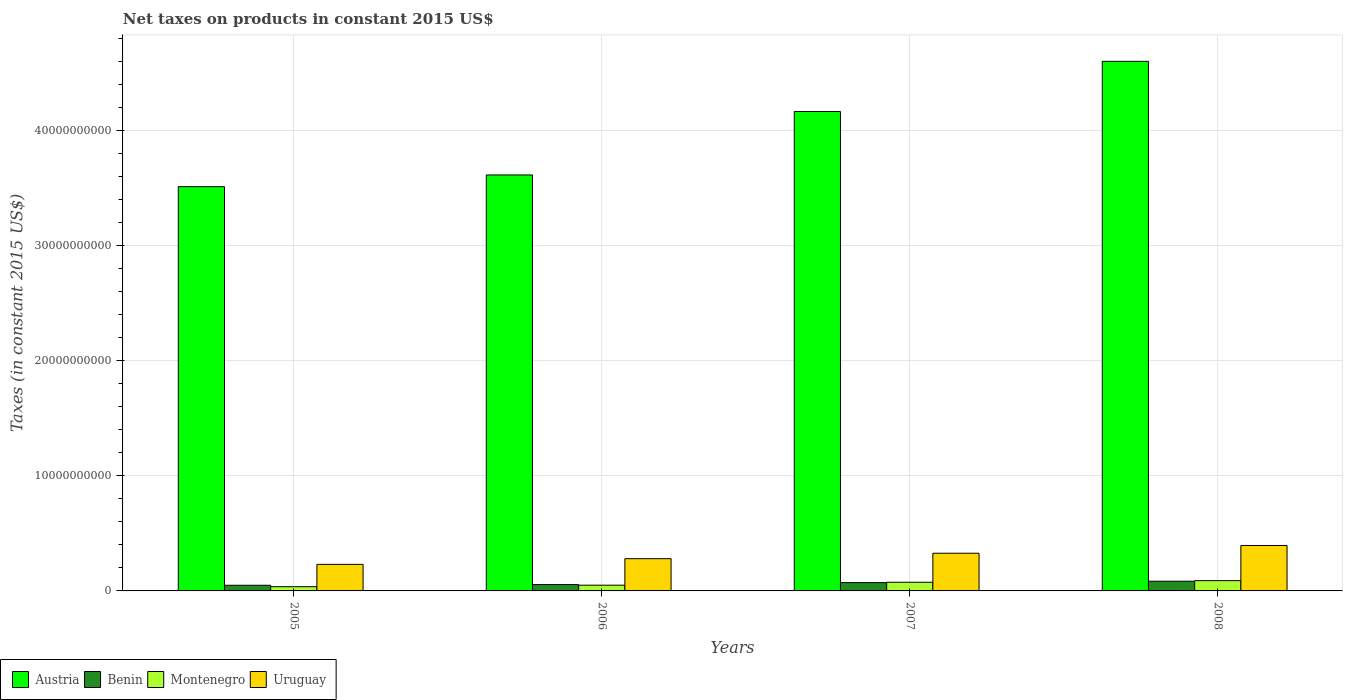How many different coloured bars are there?
Give a very brief answer. 4. Are the number of bars on each tick of the X-axis equal?
Your response must be concise. Yes. How many bars are there on the 4th tick from the left?
Make the answer very short. 4. What is the label of the 3rd group of bars from the left?
Ensure brevity in your answer.  2007. What is the net taxes on products in Montenegro in 2007?
Ensure brevity in your answer.  7.52e+08. Across all years, what is the maximum net taxes on products in Montenegro?
Offer a very short reply. 8.92e+08. Across all years, what is the minimum net taxes on products in Uruguay?
Your answer should be compact. 2.31e+09. In which year was the net taxes on products in Austria maximum?
Provide a succinct answer. 2008. What is the total net taxes on products in Uruguay in the graph?
Provide a short and direct response. 1.23e+1. What is the difference between the net taxes on products in Montenegro in 2007 and that in 2008?
Ensure brevity in your answer.  -1.40e+08. What is the difference between the net taxes on products in Uruguay in 2007 and the net taxes on products in Austria in 2006?
Your response must be concise. -3.29e+1. What is the average net taxes on products in Austria per year?
Provide a succinct answer. 3.97e+1. In the year 2008, what is the difference between the net taxes on products in Benin and net taxes on products in Uruguay?
Offer a terse response. -3.10e+09. In how many years, is the net taxes on products in Benin greater than 40000000000 US$?
Keep it short and to the point. 0. What is the ratio of the net taxes on products in Austria in 2005 to that in 2006?
Make the answer very short. 0.97. Is the difference between the net taxes on products in Benin in 2006 and 2007 greater than the difference between the net taxes on products in Uruguay in 2006 and 2007?
Offer a very short reply. Yes. What is the difference between the highest and the second highest net taxes on products in Uruguay?
Keep it short and to the point. 6.72e+08. What is the difference between the highest and the lowest net taxes on products in Austria?
Your answer should be very brief. 1.09e+1. What does the 2nd bar from the left in 2007 represents?
Offer a terse response. Benin. What does the 3rd bar from the right in 2006 represents?
Offer a terse response. Benin. Is it the case that in every year, the sum of the net taxes on products in Austria and net taxes on products in Montenegro is greater than the net taxes on products in Uruguay?
Keep it short and to the point. Yes. Are the values on the major ticks of Y-axis written in scientific E-notation?
Offer a terse response. No. Does the graph contain grids?
Your answer should be compact. Yes. How many legend labels are there?
Ensure brevity in your answer.  4. What is the title of the graph?
Give a very brief answer. Net taxes on products in constant 2015 US$. What is the label or title of the X-axis?
Keep it short and to the point. Years. What is the label or title of the Y-axis?
Your answer should be compact. Taxes (in constant 2015 US$). What is the Taxes (in constant 2015 US$) in Austria in 2005?
Offer a terse response. 3.51e+1. What is the Taxes (in constant 2015 US$) in Benin in 2005?
Your answer should be compact. 4.91e+08. What is the Taxes (in constant 2015 US$) in Montenegro in 2005?
Keep it short and to the point. 3.67e+08. What is the Taxes (in constant 2015 US$) of Uruguay in 2005?
Provide a short and direct response. 2.31e+09. What is the Taxes (in constant 2015 US$) of Austria in 2006?
Your answer should be compact. 3.61e+1. What is the Taxes (in constant 2015 US$) of Benin in 2006?
Offer a terse response. 5.49e+08. What is the Taxes (in constant 2015 US$) of Montenegro in 2006?
Offer a very short reply. 4.97e+08. What is the Taxes (in constant 2015 US$) of Uruguay in 2006?
Your response must be concise. 2.80e+09. What is the Taxes (in constant 2015 US$) of Austria in 2007?
Make the answer very short. 4.16e+1. What is the Taxes (in constant 2015 US$) in Benin in 2007?
Make the answer very short. 7.22e+08. What is the Taxes (in constant 2015 US$) of Montenegro in 2007?
Give a very brief answer. 7.52e+08. What is the Taxes (in constant 2015 US$) in Uruguay in 2007?
Make the answer very short. 3.27e+09. What is the Taxes (in constant 2015 US$) of Austria in 2008?
Offer a terse response. 4.60e+1. What is the Taxes (in constant 2015 US$) of Benin in 2008?
Your answer should be compact. 8.43e+08. What is the Taxes (in constant 2015 US$) of Montenegro in 2008?
Provide a short and direct response. 8.92e+08. What is the Taxes (in constant 2015 US$) of Uruguay in 2008?
Offer a very short reply. 3.95e+09. Across all years, what is the maximum Taxes (in constant 2015 US$) in Austria?
Your response must be concise. 4.60e+1. Across all years, what is the maximum Taxes (in constant 2015 US$) of Benin?
Provide a short and direct response. 8.43e+08. Across all years, what is the maximum Taxes (in constant 2015 US$) of Montenegro?
Offer a terse response. 8.92e+08. Across all years, what is the maximum Taxes (in constant 2015 US$) of Uruguay?
Offer a very short reply. 3.95e+09. Across all years, what is the minimum Taxes (in constant 2015 US$) in Austria?
Offer a very short reply. 3.51e+1. Across all years, what is the minimum Taxes (in constant 2015 US$) in Benin?
Provide a short and direct response. 4.91e+08. Across all years, what is the minimum Taxes (in constant 2015 US$) of Montenegro?
Your answer should be very brief. 3.67e+08. Across all years, what is the minimum Taxes (in constant 2015 US$) in Uruguay?
Your answer should be very brief. 2.31e+09. What is the total Taxes (in constant 2015 US$) of Austria in the graph?
Offer a very short reply. 1.59e+11. What is the total Taxes (in constant 2015 US$) in Benin in the graph?
Make the answer very short. 2.61e+09. What is the total Taxes (in constant 2015 US$) of Montenegro in the graph?
Your answer should be very brief. 2.51e+09. What is the total Taxes (in constant 2015 US$) in Uruguay in the graph?
Offer a very short reply. 1.23e+1. What is the difference between the Taxes (in constant 2015 US$) in Austria in 2005 and that in 2006?
Provide a succinct answer. -1.01e+09. What is the difference between the Taxes (in constant 2015 US$) of Benin in 2005 and that in 2006?
Offer a terse response. -5.88e+07. What is the difference between the Taxes (in constant 2015 US$) of Montenegro in 2005 and that in 2006?
Provide a short and direct response. -1.30e+08. What is the difference between the Taxes (in constant 2015 US$) in Uruguay in 2005 and that in 2006?
Give a very brief answer. -4.94e+08. What is the difference between the Taxes (in constant 2015 US$) in Austria in 2005 and that in 2007?
Give a very brief answer. -6.53e+09. What is the difference between the Taxes (in constant 2015 US$) of Benin in 2005 and that in 2007?
Make the answer very short. -2.31e+08. What is the difference between the Taxes (in constant 2015 US$) of Montenegro in 2005 and that in 2007?
Give a very brief answer. -3.85e+08. What is the difference between the Taxes (in constant 2015 US$) in Uruguay in 2005 and that in 2007?
Provide a succinct answer. -9.67e+08. What is the difference between the Taxes (in constant 2015 US$) of Austria in 2005 and that in 2008?
Ensure brevity in your answer.  -1.09e+1. What is the difference between the Taxes (in constant 2015 US$) in Benin in 2005 and that in 2008?
Your response must be concise. -3.52e+08. What is the difference between the Taxes (in constant 2015 US$) of Montenegro in 2005 and that in 2008?
Your response must be concise. -5.25e+08. What is the difference between the Taxes (in constant 2015 US$) in Uruguay in 2005 and that in 2008?
Offer a terse response. -1.64e+09. What is the difference between the Taxes (in constant 2015 US$) of Austria in 2006 and that in 2007?
Give a very brief answer. -5.51e+09. What is the difference between the Taxes (in constant 2015 US$) in Benin in 2006 and that in 2007?
Your response must be concise. -1.73e+08. What is the difference between the Taxes (in constant 2015 US$) in Montenegro in 2006 and that in 2007?
Your answer should be compact. -2.55e+08. What is the difference between the Taxes (in constant 2015 US$) in Uruguay in 2006 and that in 2007?
Provide a short and direct response. -4.73e+08. What is the difference between the Taxes (in constant 2015 US$) of Austria in 2006 and that in 2008?
Give a very brief answer. -9.87e+09. What is the difference between the Taxes (in constant 2015 US$) in Benin in 2006 and that in 2008?
Your answer should be very brief. -2.93e+08. What is the difference between the Taxes (in constant 2015 US$) of Montenegro in 2006 and that in 2008?
Provide a short and direct response. -3.95e+08. What is the difference between the Taxes (in constant 2015 US$) of Uruguay in 2006 and that in 2008?
Ensure brevity in your answer.  -1.14e+09. What is the difference between the Taxes (in constant 2015 US$) in Austria in 2007 and that in 2008?
Make the answer very short. -4.35e+09. What is the difference between the Taxes (in constant 2015 US$) of Benin in 2007 and that in 2008?
Your answer should be very brief. -1.21e+08. What is the difference between the Taxes (in constant 2015 US$) of Montenegro in 2007 and that in 2008?
Your answer should be very brief. -1.40e+08. What is the difference between the Taxes (in constant 2015 US$) of Uruguay in 2007 and that in 2008?
Offer a terse response. -6.72e+08. What is the difference between the Taxes (in constant 2015 US$) in Austria in 2005 and the Taxes (in constant 2015 US$) in Benin in 2006?
Offer a terse response. 3.46e+1. What is the difference between the Taxes (in constant 2015 US$) in Austria in 2005 and the Taxes (in constant 2015 US$) in Montenegro in 2006?
Make the answer very short. 3.46e+1. What is the difference between the Taxes (in constant 2015 US$) in Austria in 2005 and the Taxes (in constant 2015 US$) in Uruguay in 2006?
Offer a very short reply. 3.23e+1. What is the difference between the Taxes (in constant 2015 US$) in Benin in 2005 and the Taxes (in constant 2015 US$) in Montenegro in 2006?
Your answer should be compact. -6.38e+06. What is the difference between the Taxes (in constant 2015 US$) in Benin in 2005 and the Taxes (in constant 2015 US$) in Uruguay in 2006?
Offer a very short reply. -2.31e+09. What is the difference between the Taxes (in constant 2015 US$) in Montenegro in 2005 and the Taxes (in constant 2015 US$) in Uruguay in 2006?
Your answer should be very brief. -2.43e+09. What is the difference between the Taxes (in constant 2015 US$) of Austria in 2005 and the Taxes (in constant 2015 US$) of Benin in 2007?
Give a very brief answer. 3.44e+1. What is the difference between the Taxes (in constant 2015 US$) of Austria in 2005 and the Taxes (in constant 2015 US$) of Montenegro in 2007?
Offer a very short reply. 3.44e+1. What is the difference between the Taxes (in constant 2015 US$) in Austria in 2005 and the Taxes (in constant 2015 US$) in Uruguay in 2007?
Keep it short and to the point. 3.18e+1. What is the difference between the Taxes (in constant 2015 US$) in Benin in 2005 and the Taxes (in constant 2015 US$) in Montenegro in 2007?
Your response must be concise. -2.61e+08. What is the difference between the Taxes (in constant 2015 US$) in Benin in 2005 and the Taxes (in constant 2015 US$) in Uruguay in 2007?
Your answer should be very brief. -2.78e+09. What is the difference between the Taxes (in constant 2015 US$) in Montenegro in 2005 and the Taxes (in constant 2015 US$) in Uruguay in 2007?
Give a very brief answer. -2.91e+09. What is the difference between the Taxes (in constant 2015 US$) in Austria in 2005 and the Taxes (in constant 2015 US$) in Benin in 2008?
Your answer should be compact. 3.43e+1. What is the difference between the Taxes (in constant 2015 US$) of Austria in 2005 and the Taxes (in constant 2015 US$) of Montenegro in 2008?
Give a very brief answer. 3.42e+1. What is the difference between the Taxes (in constant 2015 US$) in Austria in 2005 and the Taxes (in constant 2015 US$) in Uruguay in 2008?
Provide a succinct answer. 3.12e+1. What is the difference between the Taxes (in constant 2015 US$) in Benin in 2005 and the Taxes (in constant 2015 US$) in Montenegro in 2008?
Your answer should be compact. -4.01e+08. What is the difference between the Taxes (in constant 2015 US$) of Benin in 2005 and the Taxes (in constant 2015 US$) of Uruguay in 2008?
Ensure brevity in your answer.  -3.45e+09. What is the difference between the Taxes (in constant 2015 US$) of Montenegro in 2005 and the Taxes (in constant 2015 US$) of Uruguay in 2008?
Ensure brevity in your answer.  -3.58e+09. What is the difference between the Taxes (in constant 2015 US$) of Austria in 2006 and the Taxes (in constant 2015 US$) of Benin in 2007?
Your response must be concise. 3.54e+1. What is the difference between the Taxes (in constant 2015 US$) of Austria in 2006 and the Taxes (in constant 2015 US$) of Montenegro in 2007?
Offer a terse response. 3.54e+1. What is the difference between the Taxes (in constant 2015 US$) of Austria in 2006 and the Taxes (in constant 2015 US$) of Uruguay in 2007?
Give a very brief answer. 3.29e+1. What is the difference between the Taxes (in constant 2015 US$) of Benin in 2006 and the Taxes (in constant 2015 US$) of Montenegro in 2007?
Your answer should be compact. -2.02e+08. What is the difference between the Taxes (in constant 2015 US$) of Benin in 2006 and the Taxes (in constant 2015 US$) of Uruguay in 2007?
Provide a succinct answer. -2.72e+09. What is the difference between the Taxes (in constant 2015 US$) of Montenegro in 2006 and the Taxes (in constant 2015 US$) of Uruguay in 2007?
Provide a succinct answer. -2.78e+09. What is the difference between the Taxes (in constant 2015 US$) of Austria in 2006 and the Taxes (in constant 2015 US$) of Benin in 2008?
Offer a very short reply. 3.53e+1. What is the difference between the Taxes (in constant 2015 US$) of Austria in 2006 and the Taxes (in constant 2015 US$) of Montenegro in 2008?
Provide a short and direct response. 3.52e+1. What is the difference between the Taxes (in constant 2015 US$) of Austria in 2006 and the Taxes (in constant 2015 US$) of Uruguay in 2008?
Ensure brevity in your answer.  3.22e+1. What is the difference between the Taxes (in constant 2015 US$) in Benin in 2006 and the Taxes (in constant 2015 US$) in Montenegro in 2008?
Provide a succinct answer. -3.43e+08. What is the difference between the Taxes (in constant 2015 US$) of Benin in 2006 and the Taxes (in constant 2015 US$) of Uruguay in 2008?
Your answer should be compact. -3.40e+09. What is the difference between the Taxes (in constant 2015 US$) of Montenegro in 2006 and the Taxes (in constant 2015 US$) of Uruguay in 2008?
Make the answer very short. -3.45e+09. What is the difference between the Taxes (in constant 2015 US$) in Austria in 2007 and the Taxes (in constant 2015 US$) in Benin in 2008?
Give a very brief answer. 4.08e+1. What is the difference between the Taxes (in constant 2015 US$) of Austria in 2007 and the Taxes (in constant 2015 US$) of Montenegro in 2008?
Provide a short and direct response. 4.07e+1. What is the difference between the Taxes (in constant 2015 US$) in Austria in 2007 and the Taxes (in constant 2015 US$) in Uruguay in 2008?
Your response must be concise. 3.77e+1. What is the difference between the Taxes (in constant 2015 US$) of Benin in 2007 and the Taxes (in constant 2015 US$) of Montenegro in 2008?
Offer a terse response. -1.70e+08. What is the difference between the Taxes (in constant 2015 US$) of Benin in 2007 and the Taxes (in constant 2015 US$) of Uruguay in 2008?
Your answer should be very brief. -3.22e+09. What is the difference between the Taxes (in constant 2015 US$) of Montenegro in 2007 and the Taxes (in constant 2015 US$) of Uruguay in 2008?
Your response must be concise. -3.19e+09. What is the average Taxes (in constant 2015 US$) of Austria per year?
Provide a short and direct response. 3.97e+1. What is the average Taxes (in constant 2015 US$) of Benin per year?
Your answer should be compact. 6.51e+08. What is the average Taxes (in constant 2015 US$) in Montenegro per year?
Provide a short and direct response. 6.27e+08. What is the average Taxes (in constant 2015 US$) in Uruguay per year?
Your response must be concise. 3.08e+09. In the year 2005, what is the difference between the Taxes (in constant 2015 US$) of Austria and Taxes (in constant 2015 US$) of Benin?
Your answer should be very brief. 3.46e+1. In the year 2005, what is the difference between the Taxes (in constant 2015 US$) of Austria and Taxes (in constant 2015 US$) of Montenegro?
Provide a short and direct response. 3.47e+1. In the year 2005, what is the difference between the Taxes (in constant 2015 US$) in Austria and Taxes (in constant 2015 US$) in Uruguay?
Make the answer very short. 3.28e+1. In the year 2005, what is the difference between the Taxes (in constant 2015 US$) of Benin and Taxes (in constant 2015 US$) of Montenegro?
Make the answer very short. 1.24e+08. In the year 2005, what is the difference between the Taxes (in constant 2015 US$) of Benin and Taxes (in constant 2015 US$) of Uruguay?
Your response must be concise. -1.82e+09. In the year 2005, what is the difference between the Taxes (in constant 2015 US$) of Montenegro and Taxes (in constant 2015 US$) of Uruguay?
Provide a succinct answer. -1.94e+09. In the year 2006, what is the difference between the Taxes (in constant 2015 US$) in Austria and Taxes (in constant 2015 US$) in Benin?
Keep it short and to the point. 3.56e+1. In the year 2006, what is the difference between the Taxes (in constant 2015 US$) in Austria and Taxes (in constant 2015 US$) in Montenegro?
Offer a terse response. 3.56e+1. In the year 2006, what is the difference between the Taxes (in constant 2015 US$) of Austria and Taxes (in constant 2015 US$) of Uruguay?
Provide a succinct answer. 3.33e+1. In the year 2006, what is the difference between the Taxes (in constant 2015 US$) in Benin and Taxes (in constant 2015 US$) in Montenegro?
Offer a terse response. 5.24e+07. In the year 2006, what is the difference between the Taxes (in constant 2015 US$) of Benin and Taxes (in constant 2015 US$) of Uruguay?
Ensure brevity in your answer.  -2.25e+09. In the year 2006, what is the difference between the Taxes (in constant 2015 US$) of Montenegro and Taxes (in constant 2015 US$) of Uruguay?
Provide a short and direct response. -2.30e+09. In the year 2007, what is the difference between the Taxes (in constant 2015 US$) in Austria and Taxes (in constant 2015 US$) in Benin?
Your answer should be very brief. 4.09e+1. In the year 2007, what is the difference between the Taxes (in constant 2015 US$) in Austria and Taxes (in constant 2015 US$) in Montenegro?
Give a very brief answer. 4.09e+1. In the year 2007, what is the difference between the Taxes (in constant 2015 US$) in Austria and Taxes (in constant 2015 US$) in Uruguay?
Keep it short and to the point. 3.84e+1. In the year 2007, what is the difference between the Taxes (in constant 2015 US$) in Benin and Taxes (in constant 2015 US$) in Montenegro?
Provide a short and direct response. -2.96e+07. In the year 2007, what is the difference between the Taxes (in constant 2015 US$) of Benin and Taxes (in constant 2015 US$) of Uruguay?
Provide a short and direct response. -2.55e+09. In the year 2007, what is the difference between the Taxes (in constant 2015 US$) in Montenegro and Taxes (in constant 2015 US$) in Uruguay?
Keep it short and to the point. -2.52e+09. In the year 2008, what is the difference between the Taxes (in constant 2015 US$) in Austria and Taxes (in constant 2015 US$) in Benin?
Your response must be concise. 4.51e+1. In the year 2008, what is the difference between the Taxes (in constant 2015 US$) of Austria and Taxes (in constant 2015 US$) of Montenegro?
Provide a short and direct response. 4.51e+1. In the year 2008, what is the difference between the Taxes (in constant 2015 US$) of Austria and Taxes (in constant 2015 US$) of Uruguay?
Keep it short and to the point. 4.20e+1. In the year 2008, what is the difference between the Taxes (in constant 2015 US$) of Benin and Taxes (in constant 2015 US$) of Montenegro?
Offer a very short reply. -4.93e+07. In the year 2008, what is the difference between the Taxes (in constant 2015 US$) of Benin and Taxes (in constant 2015 US$) of Uruguay?
Your response must be concise. -3.10e+09. In the year 2008, what is the difference between the Taxes (in constant 2015 US$) of Montenegro and Taxes (in constant 2015 US$) of Uruguay?
Your answer should be very brief. -3.05e+09. What is the ratio of the Taxes (in constant 2015 US$) of Austria in 2005 to that in 2006?
Your answer should be compact. 0.97. What is the ratio of the Taxes (in constant 2015 US$) in Benin in 2005 to that in 2006?
Your response must be concise. 0.89. What is the ratio of the Taxes (in constant 2015 US$) in Montenegro in 2005 to that in 2006?
Your response must be concise. 0.74. What is the ratio of the Taxes (in constant 2015 US$) of Uruguay in 2005 to that in 2006?
Your answer should be very brief. 0.82. What is the ratio of the Taxes (in constant 2015 US$) in Austria in 2005 to that in 2007?
Your answer should be very brief. 0.84. What is the ratio of the Taxes (in constant 2015 US$) of Benin in 2005 to that in 2007?
Provide a short and direct response. 0.68. What is the ratio of the Taxes (in constant 2015 US$) of Montenegro in 2005 to that in 2007?
Offer a very short reply. 0.49. What is the ratio of the Taxes (in constant 2015 US$) in Uruguay in 2005 to that in 2007?
Keep it short and to the point. 0.7. What is the ratio of the Taxes (in constant 2015 US$) in Austria in 2005 to that in 2008?
Make the answer very short. 0.76. What is the ratio of the Taxes (in constant 2015 US$) of Benin in 2005 to that in 2008?
Keep it short and to the point. 0.58. What is the ratio of the Taxes (in constant 2015 US$) in Montenegro in 2005 to that in 2008?
Make the answer very short. 0.41. What is the ratio of the Taxes (in constant 2015 US$) in Uruguay in 2005 to that in 2008?
Keep it short and to the point. 0.58. What is the ratio of the Taxes (in constant 2015 US$) in Austria in 2006 to that in 2007?
Ensure brevity in your answer.  0.87. What is the ratio of the Taxes (in constant 2015 US$) of Benin in 2006 to that in 2007?
Give a very brief answer. 0.76. What is the ratio of the Taxes (in constant 2015 US$) of Montenegro in 2006 to that in 2007?
Your answer should be very brief. 0.66. What is the ratio of the Taxes (in constant 2015 US$) in Uruguay in 2006 to that in 2007?
Make the answer very short. 0.86. What is the ratio of the Taxes (in constant 2015 US$) of Austria in 2006 to that in 2008?
Make the answer very short. 0.79. What is the ratio of the Taxes (in constant 2015 US$) in Benin in 2006 to that in 2008?
Provide a short and direct response. 0.65. What is the ratio of the Taxes (in constant 2015 US$) in Montenegro in 2006 to that in 2008?
Give a very brief answer. 0.56. What is the ratio of the Taxes (in constant 2015 US$) in Uruguay in 2006 to that in 2008?
Your answer should be compact. 0.71. What is the ratio of the Taxes (in constant 2015 US$) in Austria in 2007 to that in 2008?
Your response must be concise. 0.91. What is the ratio of the Taxes (in constant 2015 US$) of Benin in 2007 to that in 2008?
Provide a succinct answer. 0.86. What is the ratio of the Taxes (in constant 2015 US$) of Montenegro in 2007 to that in 2008?
Offer a very short reply. 0.84. What is the ratio of the Taxes (in constant 2015 US$) of Uruguay in 2007 to that in 2008?
Provide a succinct answer. 0.83. What is the difference between the highest and the second highest Taxes (in constant 2015 US$) of Austria?
Give a very brief answer. 4.35e+09. What is the difference between the highest and the second highest Taxes (in constant 2015 US$) of Benin?
Ensure brevity in your answer.  1.21e+08. What is the difference between the highest and the second highest Taxes (in constant 2015 US$) in Montenegro?
Provide a succinct answer. 1.40e+08. What is the difference between the highest and the second highest Taxes (in constant 2015 US$) of Uruguay?
Give a very brief answer. 6.72e+08. What is the difference between the highest and the lowest Taxes (in constant 2015 US$) in Austria?
Your response must be concise. 1.09e+1. What is the difference between the highest and the lowest Taxes (in constant 2015 US$) in Benin?
Your response must be concise. 3.52e+08. What is the difference between the highest and the lowest Taxes (in constant 2015 US$) in Montenegro?
Provide a succinct answer. 5.25e+08. What is the difference between the highest and the lowest Taxes (in constant 2015 US$) of Uruguay?
Give a very brief answer. 1.64e+09. 